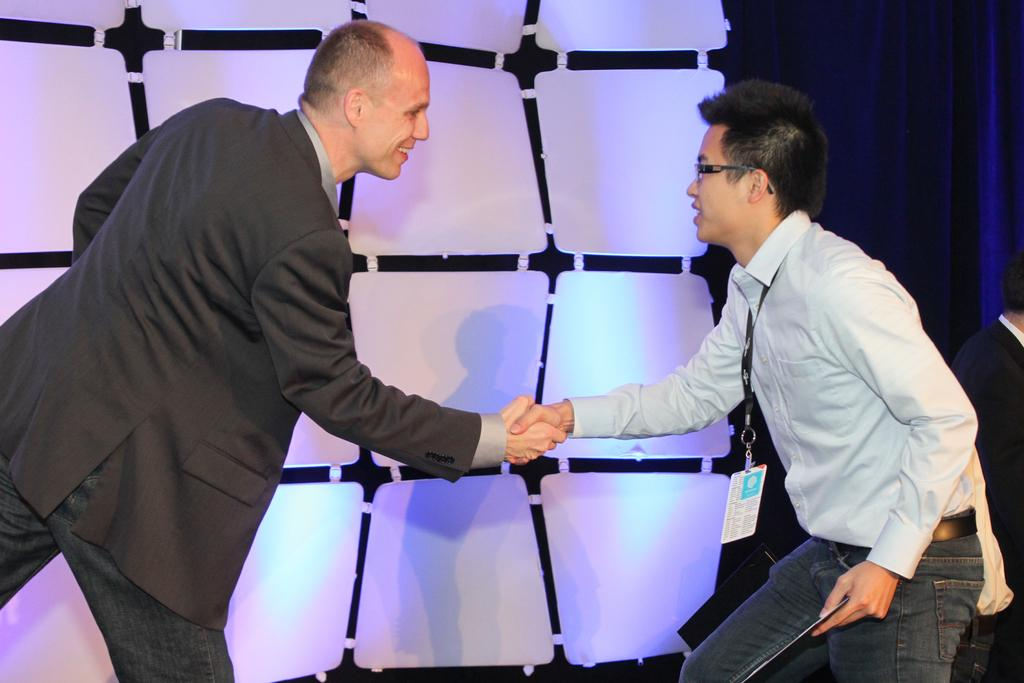How many people are in the image? There are two men in the image. What are the men doing in the image? The men are greeting each other. Can you describe the background of the image? There is a setting in the background of the image. What color is the curtain beside the setting? There is a blue curtain beside the setting. What type of oatmeal is being served in the jar on the table in the image? There is no jar or oatmeal present in the image. What kind of branch can be seen growing from the blue curtain in the image? There is no branch visible in the image, and the blue curtain is not mentioned as having any branches. 